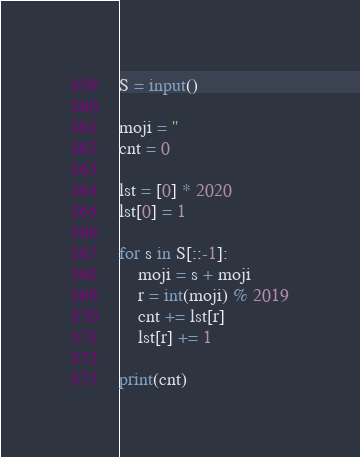<code> <loc_0><loc_0><loc_500><loc_500><_Python_>S = input()

moji = ''
cnt = 0

lst = [0] * 2020
lst[0] = 1

for s in S[::-1]:
    moji = s + moji
    r = int(moji) % 2019
    cnt += lst[r]
    lst[r] += 1

print(cnt)
</code> 